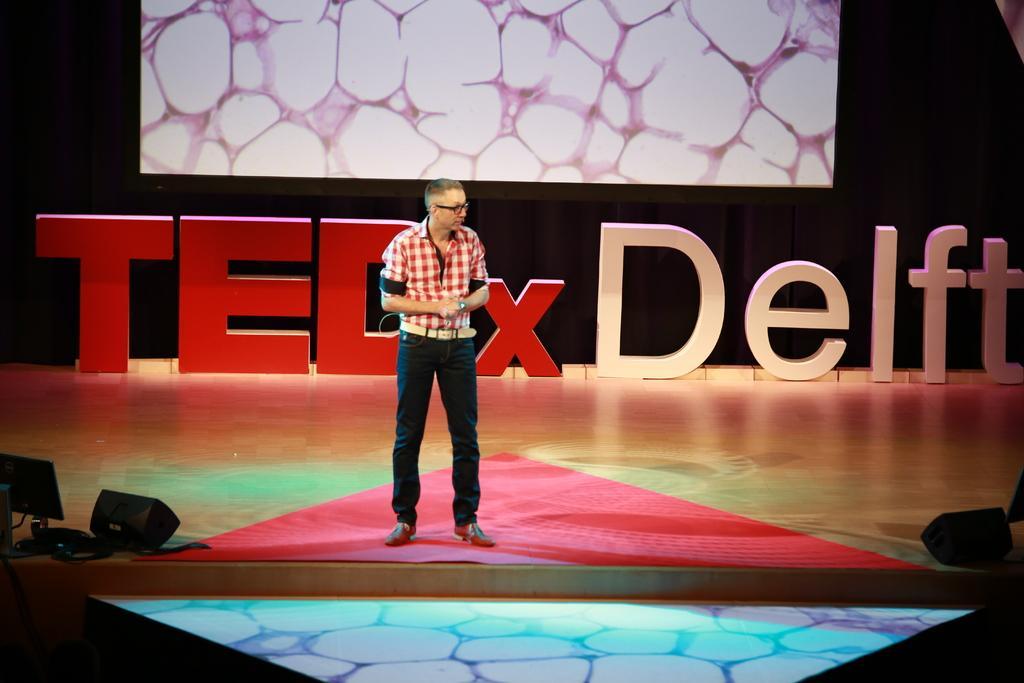Please provide a concise description of this image. In this image, there is a person standing on the stage. This person is wearing clothes and spectacles. There is light in the bottom left and in the bottom right of the image. There is a screen at the top of the image. 